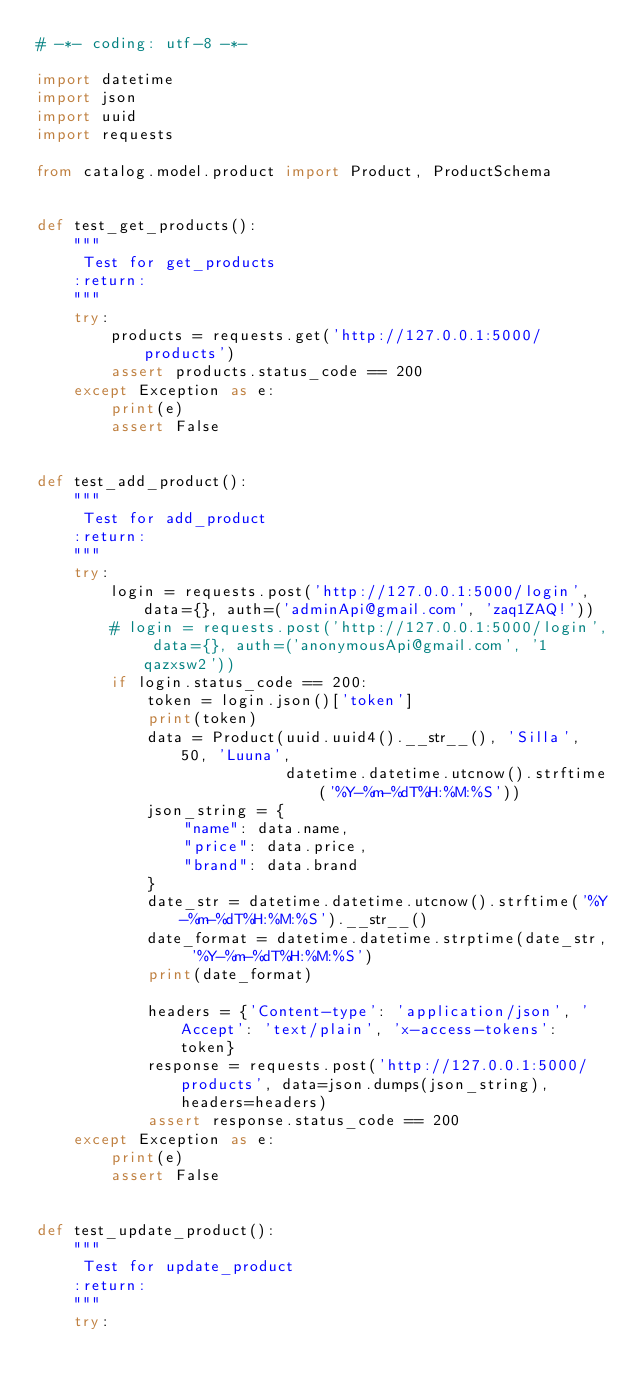<code> <loc_0><loc_0><loc_500><loc_500><_Python_># -*- coding: utf-8 -*-

import datetime
import json
import uuid
import requests

from catalog.model.product import Product, ProductSchema


def test_get_products():
    """
     Test for get_products
    :return:
    """
    try:
        products = requests.get('http://127.0.0.1:5000/products')
        assert products.status_code == 200
    except Exception as e:
        print(e)
        assert False


def test_add_product():
    """
     Test for add_product
    :return:
    """
    try:
        login = requests.post('http://127.0.0.1:5000/login', data={}, auth=('adminApi@gmail.com', 'zaq1ZAQ!'))
        # login = requests.post('http://127.0.0.1:5000/login', data={}, auth=('anonymousApi@gmail.com', '1qazxsw2'))
        if login.status_code == 200:
            token = login.json()['token']
            print(token)
            data = Product(uuid.uuid4().__str__(), 'Silla', 50, 'Luuna',
                           datetime.datetime.utcnow().strftime('%Y-%m-%dT%H:%M:%S'))
            json_string = {
                "name": data.name,
                "price": data.price,
                "brand": data.brand
            }
            date_str = datetime.datetime.utcnow().strftime('%Y-%m-%dT%H:%M:%S').__str__()
            date_format = datetime.datetime.strptime(date_str, '%Y-%m-%dT%H:%M:%S')
            print(date_format)

            headers = {'Content-type': 'application/json', 'Accept': 'text/plain', 'x-access-tokens': token}
            response = requests.post('http://127.0.0.1:5000/products', data=json.dumps(json_string), headers=headers)
            assert response.status_code == 200
    except Exception as e:
        print(e)
        assert False


def test_update_product():
    """
     Test for update_product
    :return:
    """
    try:</code> 